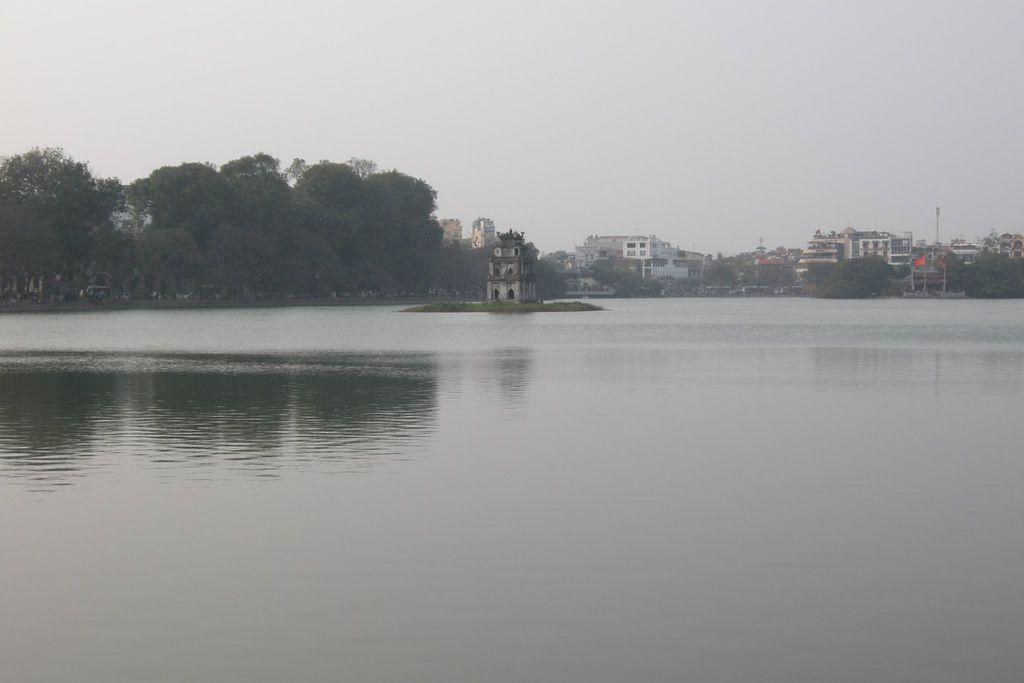Describe this image in one or two sentences. In the center of the image there is a building on the water. In the background we can see trees, buildings, tower and sky. At the bottom there is water. 